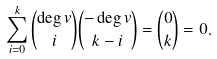Convert formula to latex. <formula><loc_0><loc_0><loc_500><loc_500>\sum _ { i = 0 } ^ { k } \binom { \deg v } { i } \binom { - \deg v } { k - i } = \binom { 0 } { k } = 0 .</formula> 